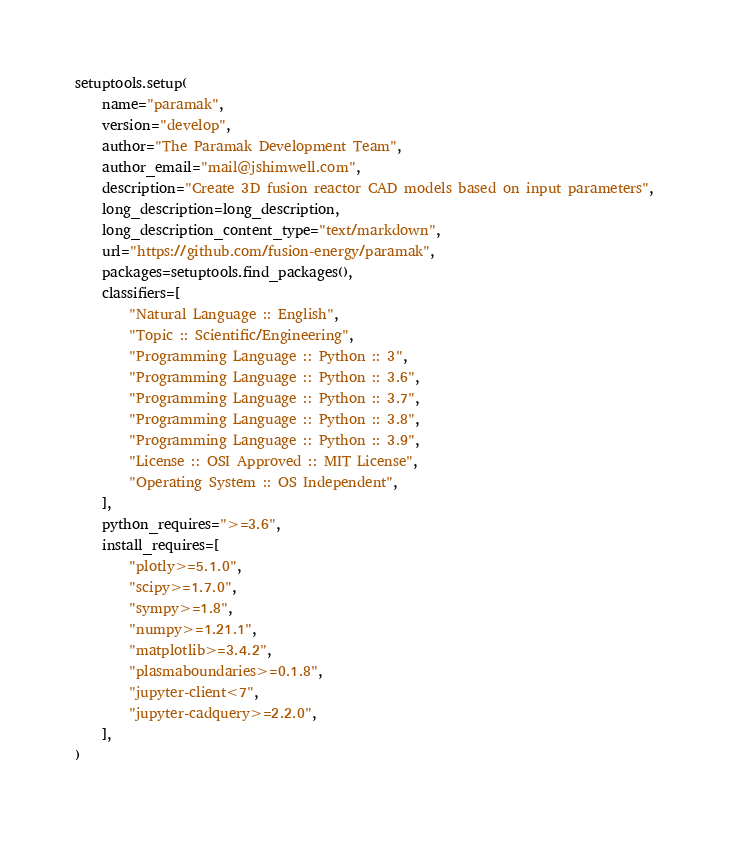<code> <loc_0><loc_0><loc_500><loc_500><_Python_>setuptools.setup(
    name="paramak",
    version="develop",
    author="The Paramak Development Team",
    author_email="mail@jshimwell.com",
    description="Create 3D fusion reactor CAD models based on input parameters",
    long_description=long_description,
    long_description_content_type="text/markdown",
    url="https://github.com/fusion-energy/paramak",
    packages=setuptools.find_packages(),
    classifiers=[
        "Natural Language :: English",
        "Topic :: Scientific/Engineering",
        "Programming Language :: Python :: 3",
        "Programming Language :: Python :: 3.6",
        "Programming Language :: Python :: 3.7",
        "Programming Language :: Python :: 3.8",
        "Programming Language :: Python :: 3.9",
        "License :: OSI Approved :: MIT License",
        "Operating System :: OS Independent",
    ],
    python_requires=">=3.6",
    install_requires=[
        "plotly>=5.1.0",
        "scipy>=1.7.0",
        "sympy>=1.8",
        "numpy>=1.21.1",
        "matplotlib>=3.4.2",
        "plasmaboundaries>=0.1.8",
        "jupyter-client<7",
        "jupyter-cadquery>=2.2.0",
    ],
)
</code> 